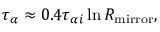Convert formula to latex. <formula><loc_0><loc_0><loc_500><loc_500>\tau _ { \alpha } \approx 0 . 4 \tau _ { \alpha i } \ln R _ { m i r r o r } ,</formula> 